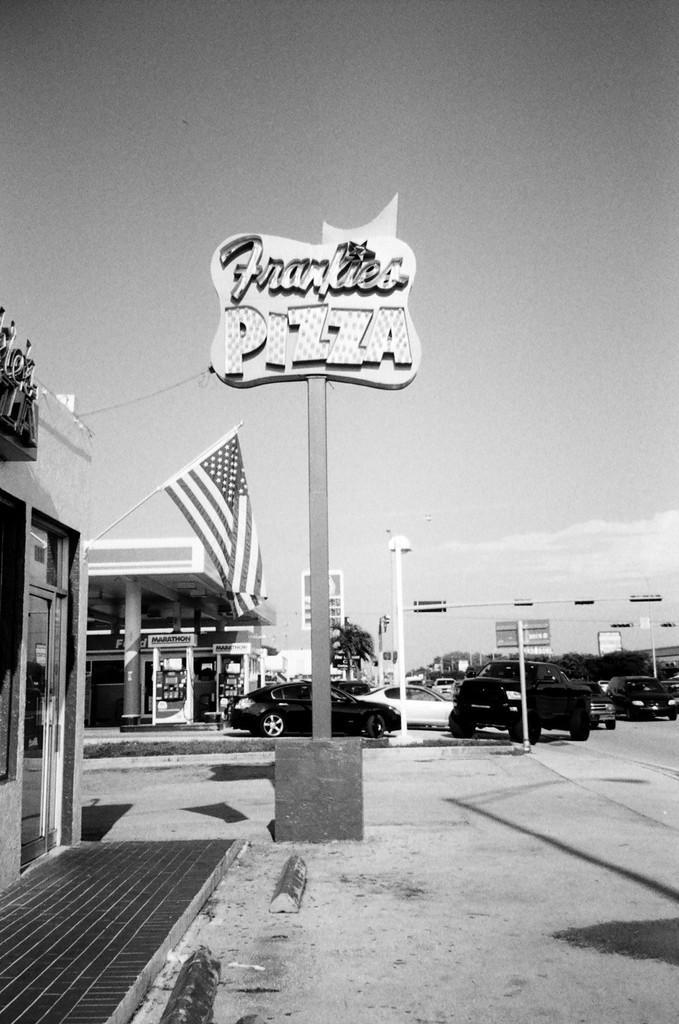In one or two sentences, can you explain what this image depicts? In the foreground of the image we can see a road. In the middle of the image we can see petrol bunk, cars and the flag. On the top of the image we can see a board on which some text is written and the sky. 